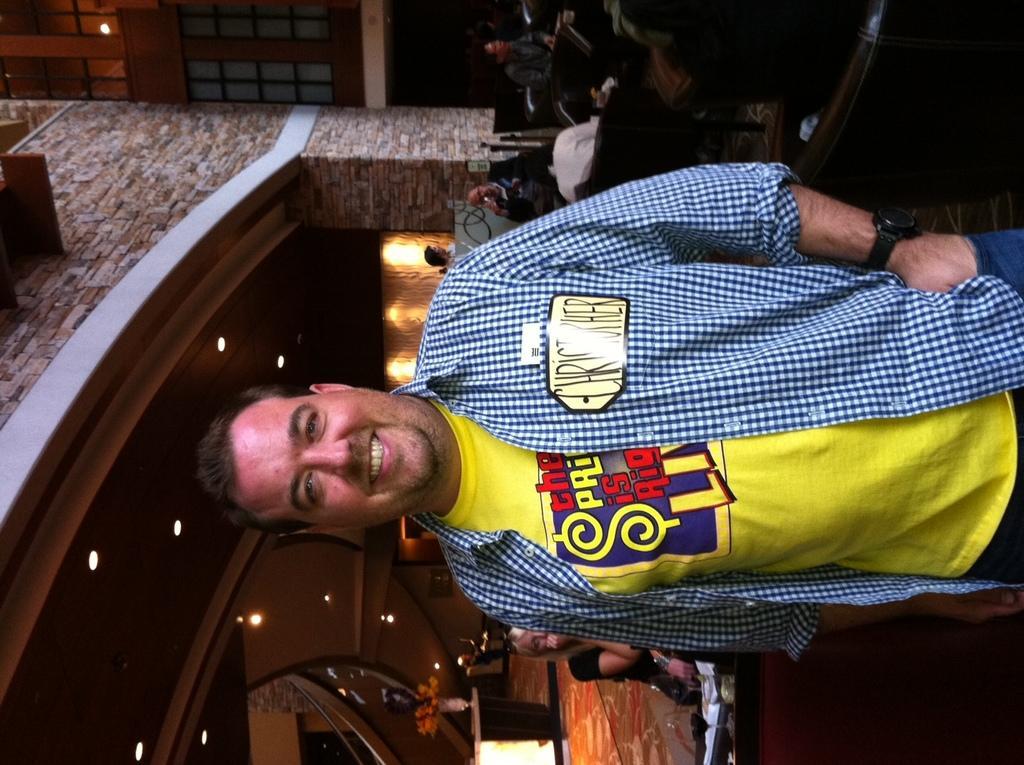Could you give a brief overview of what you see in this image? In this picture we can see a person with yellow color T-Shirt and blue color shirt and a watch to his hand and back of him we can see some people sitting on the chair and background we can see building with windows,lights,flower vase ,table and floor. 